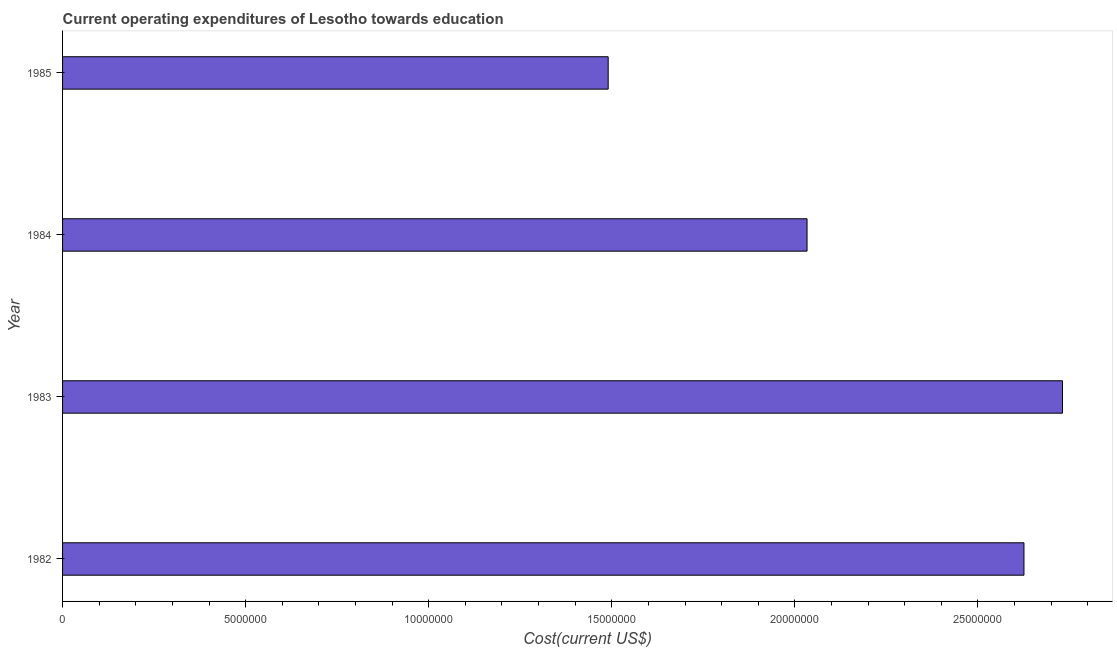Does the graph contain any zero values?
Your response must be concise. No. What is the title of the graph?
Your answer should be very brief. Current operating expenditures of Lesotho towards education. What is the label or title of the X-axis?
Give a very brief answer. Cost(current US$). What is the label or title of the Y-axis?
Your answer should be compact. Year. What is the education expenditure in 1985?
Provide a succinct answer. 1.49e+07. Across all years, what is the maximum education expenditure?
Your response must be concise. 2.73e+07. Across all years, what is the minimum education expenditure?
Your response must be concise. 1.49e+07. What is the sum of the education expenditure?
Your answer should be compact. 8.88e+07. What is the difference between the education expenditure in 1983 and 1984?
Offer a very short reply. 6.98e+06. What is the average education expenditure per year?
Keep it short and to the point. 2.22e+07. What is the median education expenditure?
Make the answer very short. 2.33e+07. Do a majority of the years between 1982 and 1983 (inclusive) have education expenditure greater than 6000000 US$?
Keep it short and to the point. Yes. What is the ratio of the education expenditure in 1983 to that in 1985?
Ensure brevity in your answer.  1.83. What is the difference between the highest and the second highest education expenditure?
Offer a very short reply. 1.05e+06. What is the difference between the highest and the lowest education expenditure?
Your answer should be compact. 1.24e+07. In how many years, is the education expenditure greater than the average education expenditure taken over all years?
Give a very brief answer. 2. How many bars are there?
Your answer should be very brief. 4. Are all the bars in the graph horizontal?
Offer a very short reply. Yes. Are the values on the major ticks of X-axis written in scientific E-notation?
Offer a terse response. No. What is the Cost(current US$) of 1982?
Keep it short and to the point. 2.63e+07. What is the Cost(current US$) of 1983?
Your answer should be very brief. 2.73e+07. What is the Cost(current US$) of 1984?
Make the answer very short. 2.03e+07. What is the Cost(current US$) of 1985?
Your response must be concise. 1.49e+07. What is the difference between the Cost(current US$) in 1982 and 1983?
Provide a succinct answer. -1.05e+06. What is the difference between the Cost(current US$) in 1982 and 1984?
Your answer should be compact. 5.92e+06. What is the difference between the Cost(current US$) in 1982 and 1985?
Make the answer very short. 1.14e+07. What is the difference between the Cost(current US$) in 1983 and 1984?
Provide a succinct answer. 6.98e+06. What is the difference between the Cost(current US$) in 1983 and 1985?
Give a very brief answer. 1.24e+07. What is the difference between the Cost(current US$) in 1984 and 1985?
Provide a succinct answer. 5.43e+06. What is the ratio of the Cost(current US$) in 1982 to that in 1984?
Make the answer very short. 1.29. What is the ratio of the Cost(current US$) in 1982 to that in 1985?
Keep it short and to the point. 1.76. What is the ratio of the Cost(current US$) in 1983 to that in 1984?
Provide a succinct answer. 1.34. What is the ratio of the Cost(current US$) in 1983 to that in 1985?
Provide a short and direct response. 1.83. What is the ratio of the Cost(current US$) in 1984 to that in 1985?
Offer a terse response. 1.36. 